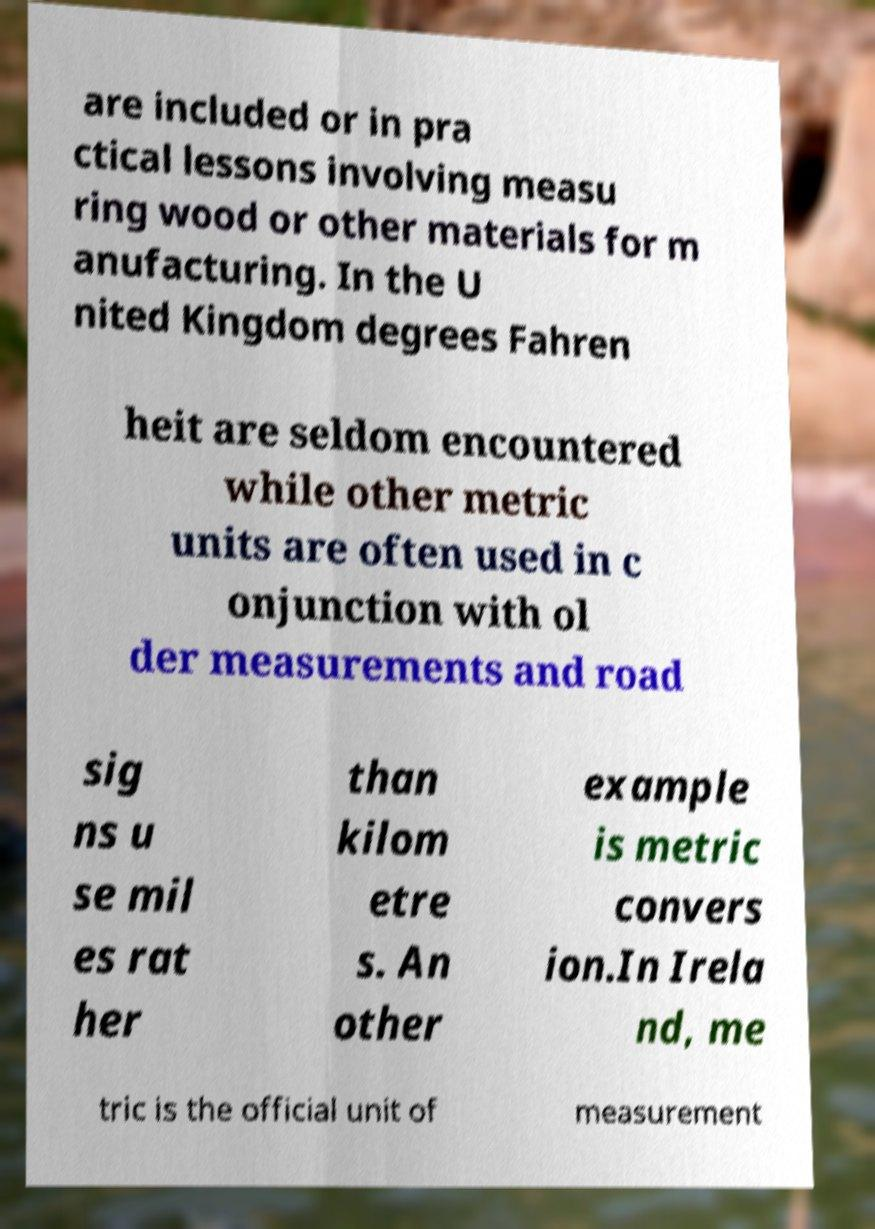I need the written content from this picture converted into text. Can you do that? are included or in pra ctical lessons involving measu ring wood or other materials for m anufacturing. In the U nited Kingdom degrees Fahren heit are seldom encountered while other metric units are often used in c onjunction with ol der measurements and road sig ns u se mil es rat her than kilom etre s. An other example is metric convers ion.In Irela nd, me tric is the official unit of measurement 